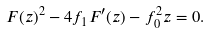<formula> <loc_0><loc_0><loc_500><loc_500>F ( z ) ^ { 2 } - 4 f _ { 1 } F ^ { \prime } ( z ) - f _ { 0 } ^ { 2 } z = 0 .</formula> 